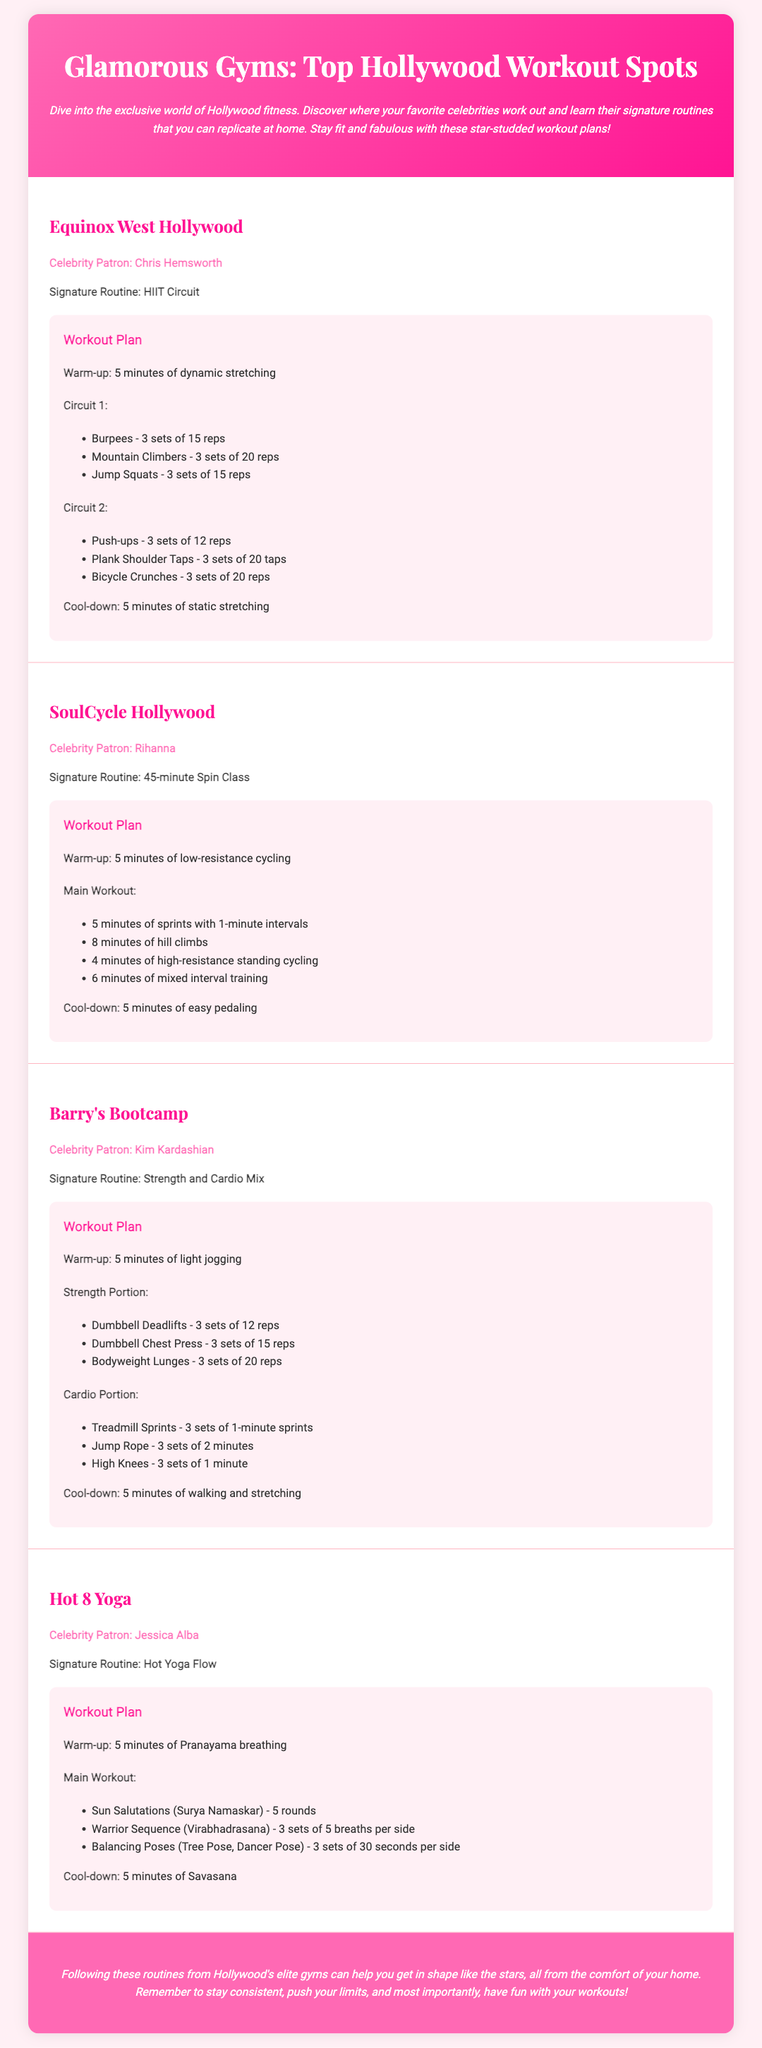What is the signature routine of Chris Hemsworth at Equinox West Hollywood? The signature routine is a HIIT Circuit.
Answer: HIIT Circuit How many sets of Burpees are included in Chris Hemsworth's workout plan? The workout plan states 3 sets of Burpees.
Answer: 3 sets Which celebrity is associated with SoulCycle Hollywood? The document mentions Rihanna as the celebrity patron.
Answer: Rihanna How long is the main workout at SoulCycle? The main workout consists of a 45-minute Spin Class.
Answer: 45-minute What is the cool-down time for the workout at Barry's Bootcamp? The cool-down consists of 5 minutes of walking and stretching.
Answer: 5 minutes What type of yoga routine does Jessica Alba practice at Hot 8 Yoga? The type of routine is called Hot Yoga Flow.
Answer: Hot Yoga Flow What is the warm-up included in Kim Kardashian's workout at Barry's Bootcamp? The warm-up is 5 minutes of light jogging.
Answer: 5 minutes of light jogging What exercise involves 5 rounds in the main workout at Hot 8 Yoga? The main workout includes Sun Salutations.
Answer: Sun Salutations Which gym features a signature routine that includes high-resistance standing cycling? This routine is found at SoulCycle Hollywood.
Answer: SoulCycle Hollywood 